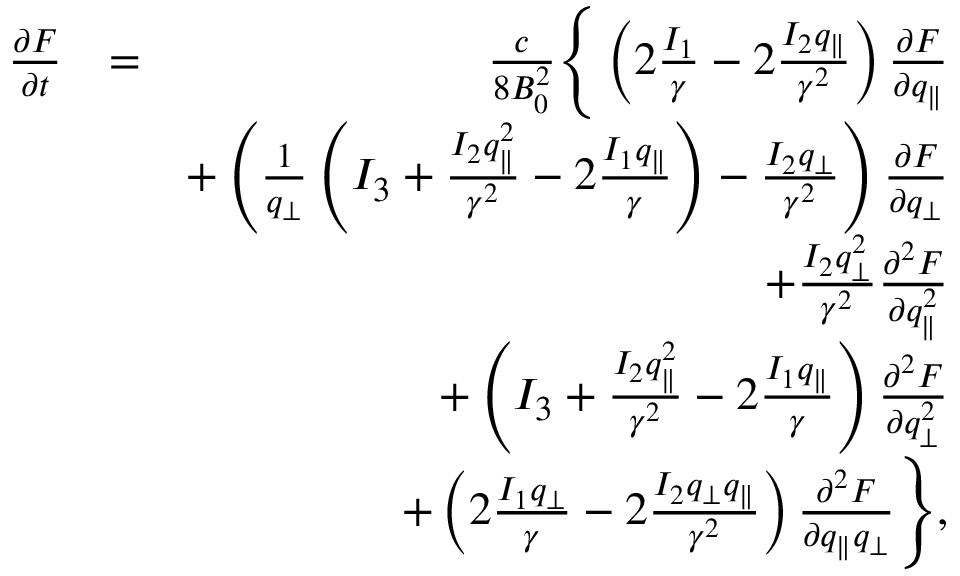Convert formula to latex. <formula><loc_0><loc_0><loc_500><loc_500>\begin{array} { r l r } { \frac { \partial F } { \partial t } } & { = } & { \frac { c } { 8 B _ { 0 } ^ { 2 } } \left \{ \left ( 2 \frac { I _ { 1 } } { \gamma } - 2 \frac { I _ { 2 } q _ { \| } } { \gamma ^ { 2 } } \right ) \frac { \partial F } { \partial q _ { \| } } } \\ & { + \left ( \frac { 1 } { q _ { \perp } } \left ( I _ { 3 } + \frac { I _ { 2 } q _ { \| } ^ { 2 } } { \gamma ^ { 2 } } - 2 \frac { I _ { 1 } q _ { \| } } { \gamma } \right ) - \frac { I _ { 2 } q _ { \perp } } { \gamma ^ { 2 } } \right ) \frac { \partial F } { \partial q _ { \perp } } } \\ & { + \frac { I _ { 2 } q _ { \perp } ^ { 2 } } { \gamma ^ { 2 } } \frac { \partial ^ { 2 } F } { \partial q _ { \| } ^ { 2 } } } \\ & { + \left ( I _ { 3 } + \frac { I _ { 2 } q _ { \| } ^ { 2 } } { \gamma ^ { 2 } } - 2 \frac { I _ { 1 } q _ { \| } } { \gamma } \right ) \frac { \partial ^ { 2 } F } { \partial q _ { \perp } ^ { 2 } } } \\ & { + \left ( 2 \frac { I _ { 1 } q _ { \perp } } { \gamma } - 2 \frac { I _ { 2 } q _ { \perp } q _ { \| } } { \gamma ^ { 2 } } \right ) \frac { \partial ^ { 2 } F } { \partial q _ { \| } q _ { \perp } } \right \} , } \end{array}</formula> 